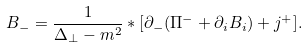Convert formula to latex. <formula><loc_0><loc_0><loc_500><loc_500>B _ { - } = \frac { 1 } { \Delta _ { \perp } - m ^ { 2 } } * [ \partial _ { - } ( \Pi ^ { - } + \partial _ { i } B _ { i } ) + j ^ { + } ] .</formula> 